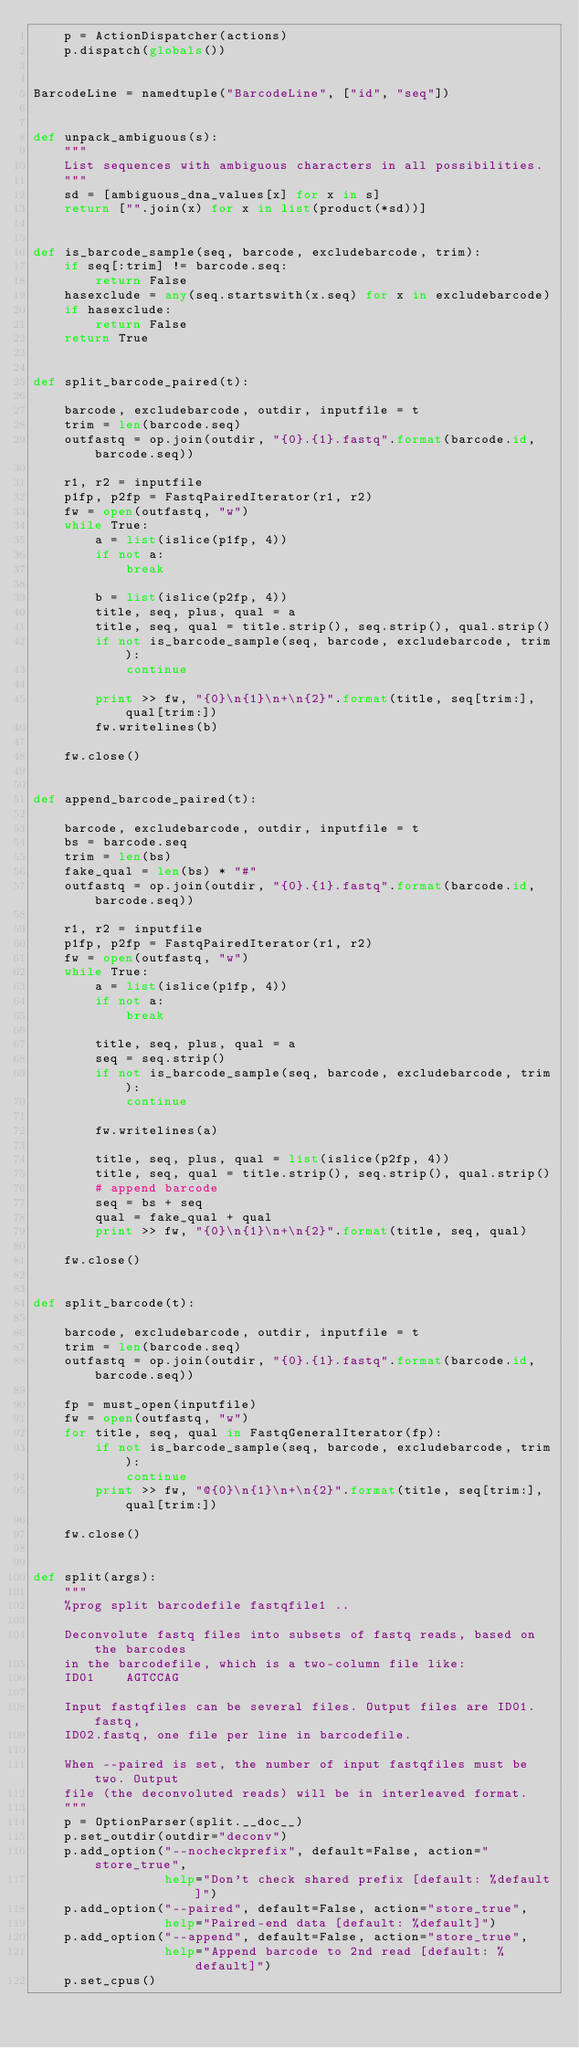<code> <loc_0><loc_0><loc_500><loc_500><_Python_>    p = ActionDispatcher(actions)
    p.dispatch(globals())


BarcodeLine = namedtuple("BarcodeLine", ["id", "seq"])


def unpack_ambiguous(s):
    """
    List sequences with ambiguous characters in all possibilities.
    """
    sd = [ambiguous_dna_values[x] for x in s]
    return ["".join(x) for x in list(product(*sd))]


def is_barcode_sample(seq, barcode, excludebarcode, trim):
    if seq[:trim] != barcode.seq:
        return False
    hasexclude = any(seq.startswith(x.seq) for x in excludebarcode)
    if hasexclude:
        return False
    return True


def split_barcode_paired(t):

    barcode, excludebarcode, outdir, inputfile = t
    trim = len(barcode.seq)
    outfastq = op.join(outdir, "{0}.{1}.fastq".format(barcode.id, barcode.seq))

    r1, r2 = inputfile
    p1fp, p2fp = FastqPairedIterator(r1, r2)
    fw = open(outfastq, "w")
    while True:
        a = list(islice(p1fp, 4))
        if not a:
            break

        b = list(islice(p2fp, 4))
        title, seq, plus, qual = a
        title, seq, qual = title.strip(), seq.strip(), qual.strip()
        if not is_barcode_sample(seq, barcode, excludebarcode, trim):
            continue

        print >> fw, "{0}\n{1}\n+\n{2}".format(title, seq[trim:], qual[trim:])
        fw.writelines(b)

    fw.close()


def append_barcode_paired(t):

    barcode, excludebarcode, outdir, inputfile = t
    bs = barcode.seq
    trim = len(bs)
    fake_qual = len(bs) * "#"
    outfastq = op.join(outdir, "{0}.{1}.fastq".format(barcode.id, barcode.seq))

    r1, r2 = inputfile
    p1fp, p2fp = FastqPairedIterator(r1, r2)
    fw = open(outfastq, "w")
    while True:
        a = list(islice(p1fp, 4))
        if not a:
            break

        title, seq, plus, qual = a
        seq = seq.strip()
        if not is_barcode_sample(seq, barcode, excludebarcode, trim):
            continue

        fw.writelines(a)

        title, seq, plus, qual = list(islice(p2fp, 4))
        title, seq, qual = title.strip(), seq.strip(), qual.strip()
        # append barcode
        seq = bs + seq
        qual = fake_qual + qual
        print >> fw, "{0}\n{1}\n+\n{2}".format(title, seq, qual)

    fw.close()


def split_barcode(t):

    barcode, excludebarcode, outdir, inputfile = t
    trim = len(barcode.seq)
    outfastq = op.join(outdir, "{0}.{1}.fastq".format(barcode.id, barcode.seq))

    fp = must_open(inputfile)
    fw = open(outfastq, "w")
    for title, seq, qual in FastqGeneralIterator(fp):
        if not is_barcode_sample(seq, barcode, excludebarcode, trim):
            continue
        print >> fw, "@{0}\n{1}\n+\n{2}".format(title, seq[trim:], qual[trim:])

    fw.close()


def split(args):
    """
    %prog split barcodefile fastqfile1 ..

    Deconvolute fastq files into subsets of fastq reads, based on the barcodes
    in the barcodefile, which is a two-column file like:
    ID01	AGTCCAG

    Input fastqfiles can be several files. Output files are ID01.fastq,
    ID02.fastq, one file per line in barcodefile.

    When --paired is set, the number of input fastqfiles must be two. Output
    file (the deconvoluted reads) will be in interleaved format.
    """
    p = OptionParser(split.__doc__)
    p.set_outdir(outdir="deconv")
    p.add_option("--nocheckprefix", default=False, action="store_true",
                 help="Don't check shared prefix [default: %default]")
    p.add_option("--paired", default=False, action="store_true",
                 help="Paired-end data [default: %default]")
    p.add_option("--append", default=False, action="store_true",
                 help="Append barcode to 2nd read [default: %default]")
    p.set_cpus()</code> 